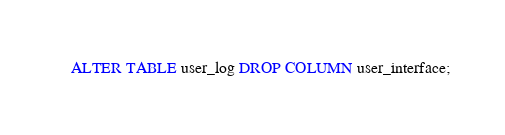Convert code to text. <code><loc_0><loc_0><loc_500><loc_500><_SQL_>ALTER TABLE user_log DROP COLUMN user_interface;</code> 